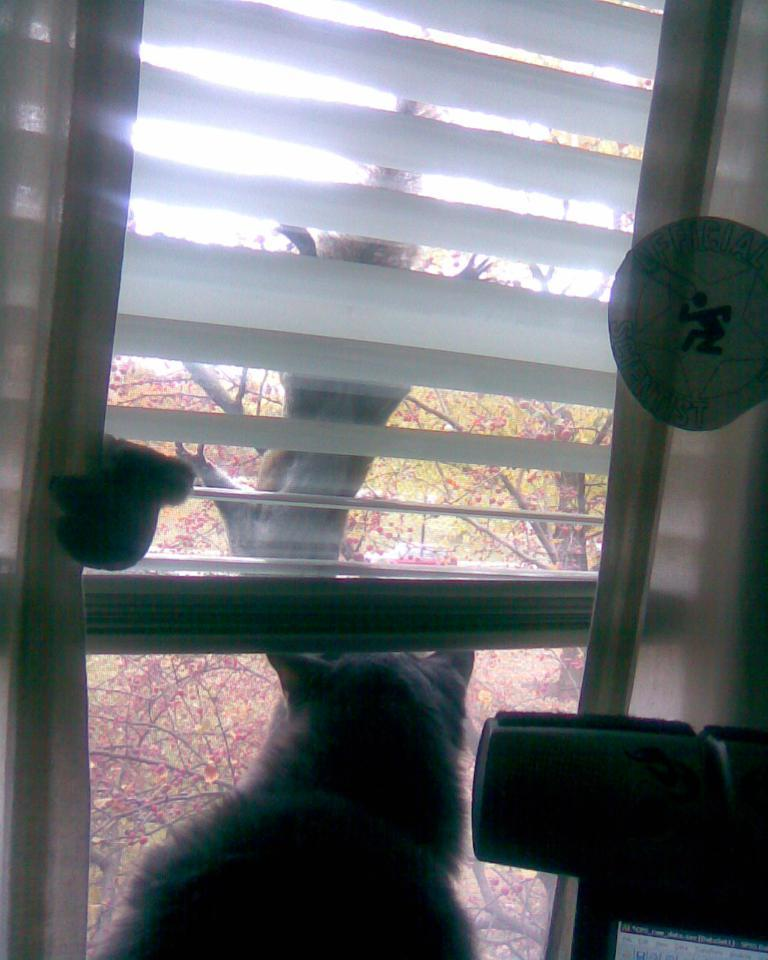What animal is visible in the image? There is a cat in the image. What is the cat doing in the image? The cat is viewing from a window. What can be seen in the background of the image? There are trees in the background of the image. What type of sign is the cat holding in the image? There is no sign present in the image; it features a cat viewing from a window. What nation is the cat representing in the image? The image does not depict the cat representing any specific nation. 